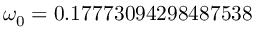Convert formula to latex. <formula><loc_0><loc_0><loc_500><loc_500>\omega _ { 0 } = 0 . 1 7 7 7 3 0 9 4 2 9 8 4 8 7 5 3 8</formula> 